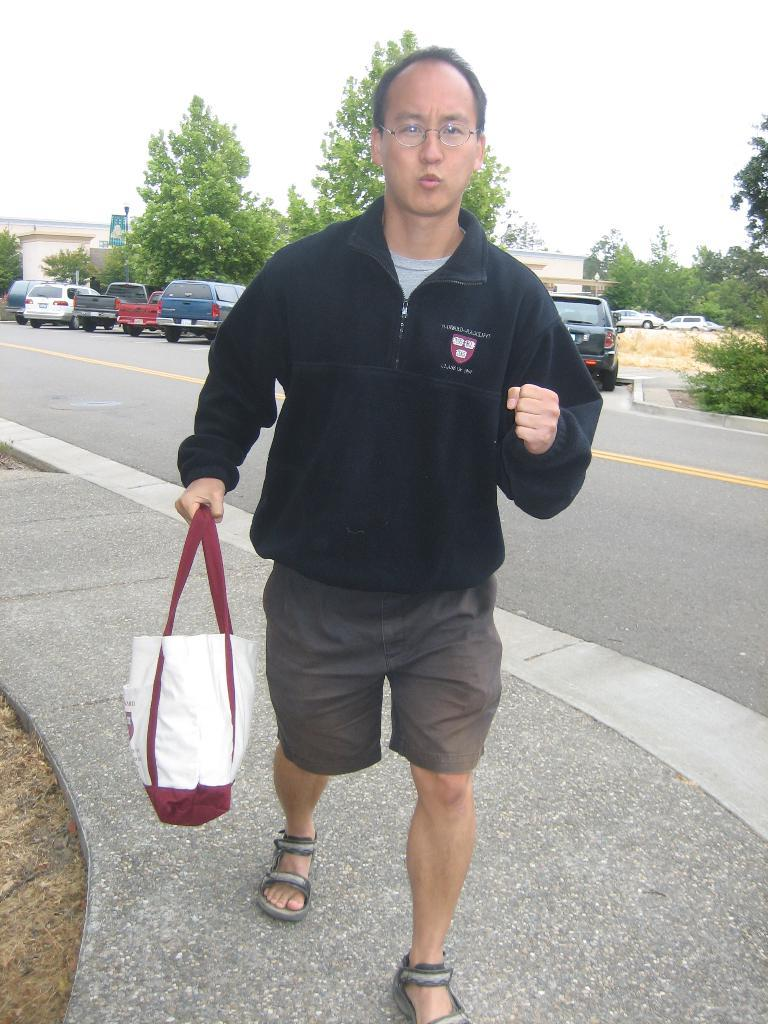Who is present in the image? There is a man in the image. What is the man holding in the image? The man is holding a bag. What can be seen in the background of the image? There are vehicles and trees visible in the background of the image. How many clocks are visible in the image? There are no clocks present in the image. What type of mark can be seen on the man's shirt in the image? There is no mark visible on the man's shirt in the image. 